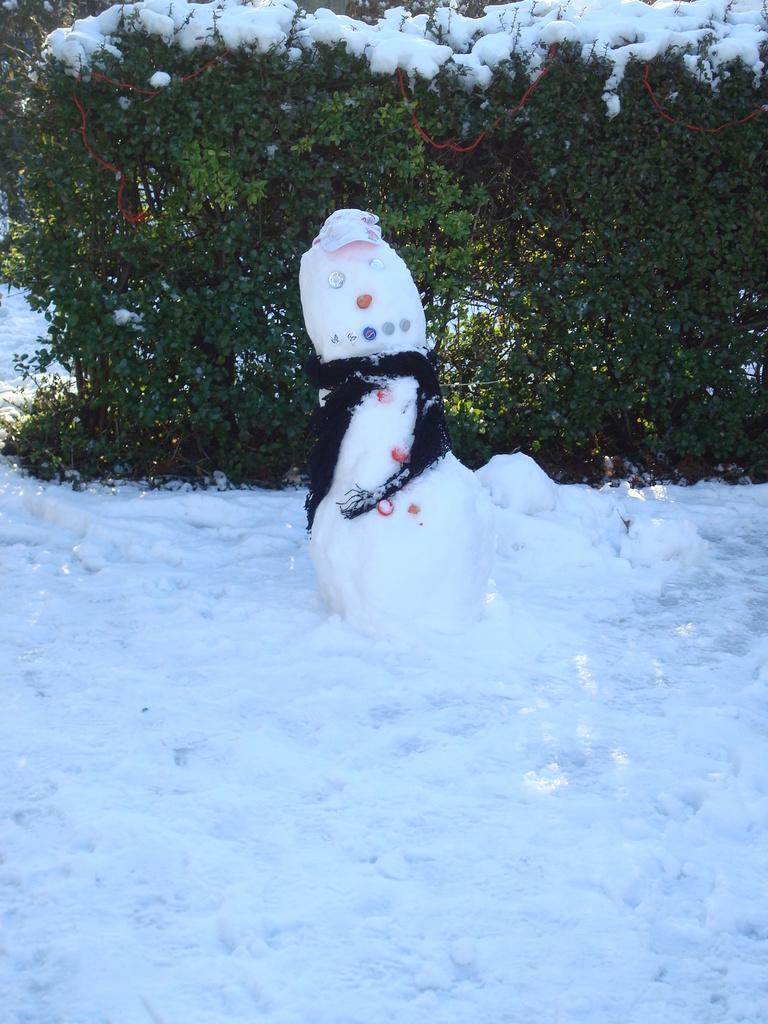What type of living organisms can be seen in the image? Plants can be seen in the image. What is the weather condition in the image? There is snow visible in the image, indicating a cold and snowy environment. What additional object is present in the image, related to the snow? There is a snow doll in the image. Can you tell me what type of wire is being used to hold the party decorations in the image? There is no party or decorations present in the image, so there is no wire being used for that purpose. 